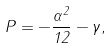Convert formula to latex. <formula><loc_0><loc_0><loc_500><loc_500>P = - \frac { \alpha ^ { 2 } } { 1 2 } - \gamma ,</formula> 